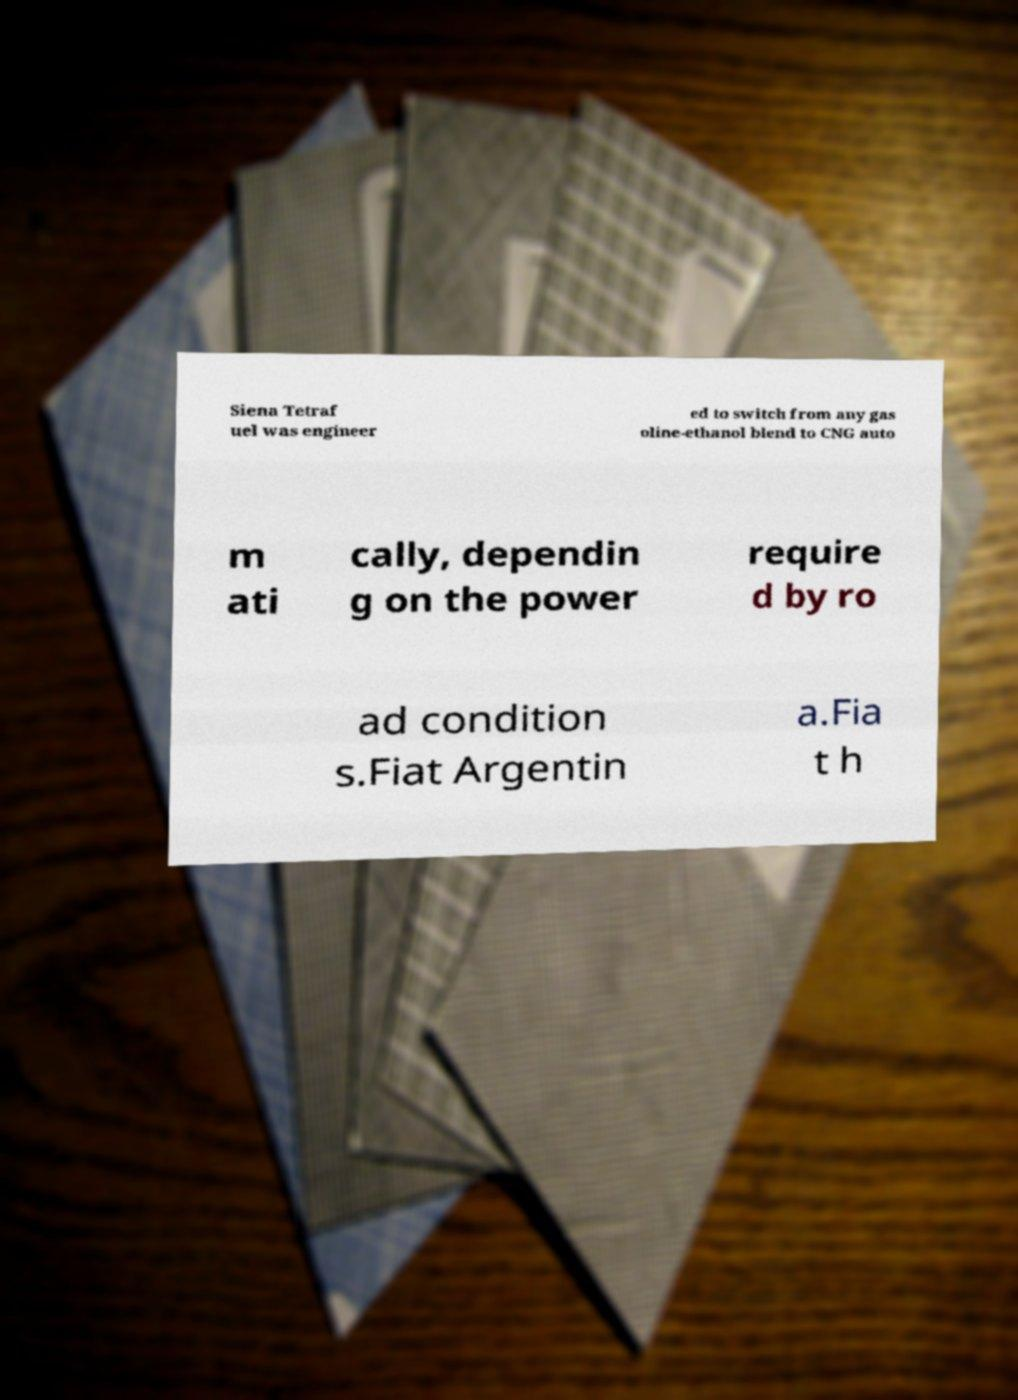There's text embedded in this image that I need extracted. Can you transcribe it verbatim? Siena Tetraf uel was engineer ed to switch from any gas oline-ethanol blend to CNG auto m ati cally, dependin g on the power require d by ro ad condition s.Fiat Argentin a.Fia t h 